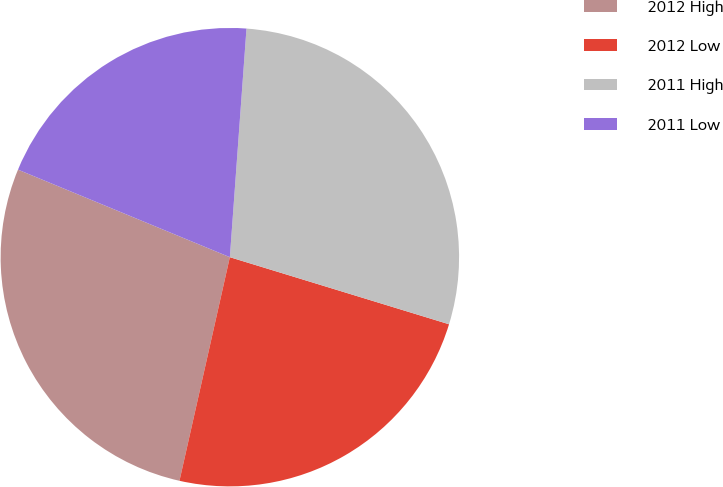<chart> <loc_0><loc_0><loc_500><loc_500><pie_chart><fcel>2012 High<fcel>2012 Low<fcel>2011 High<fcel>2011 Low<nl><fcel>27.71%<fcel>23.8%<fcel>28.57%<fcel>19.92%<nl></chart> 